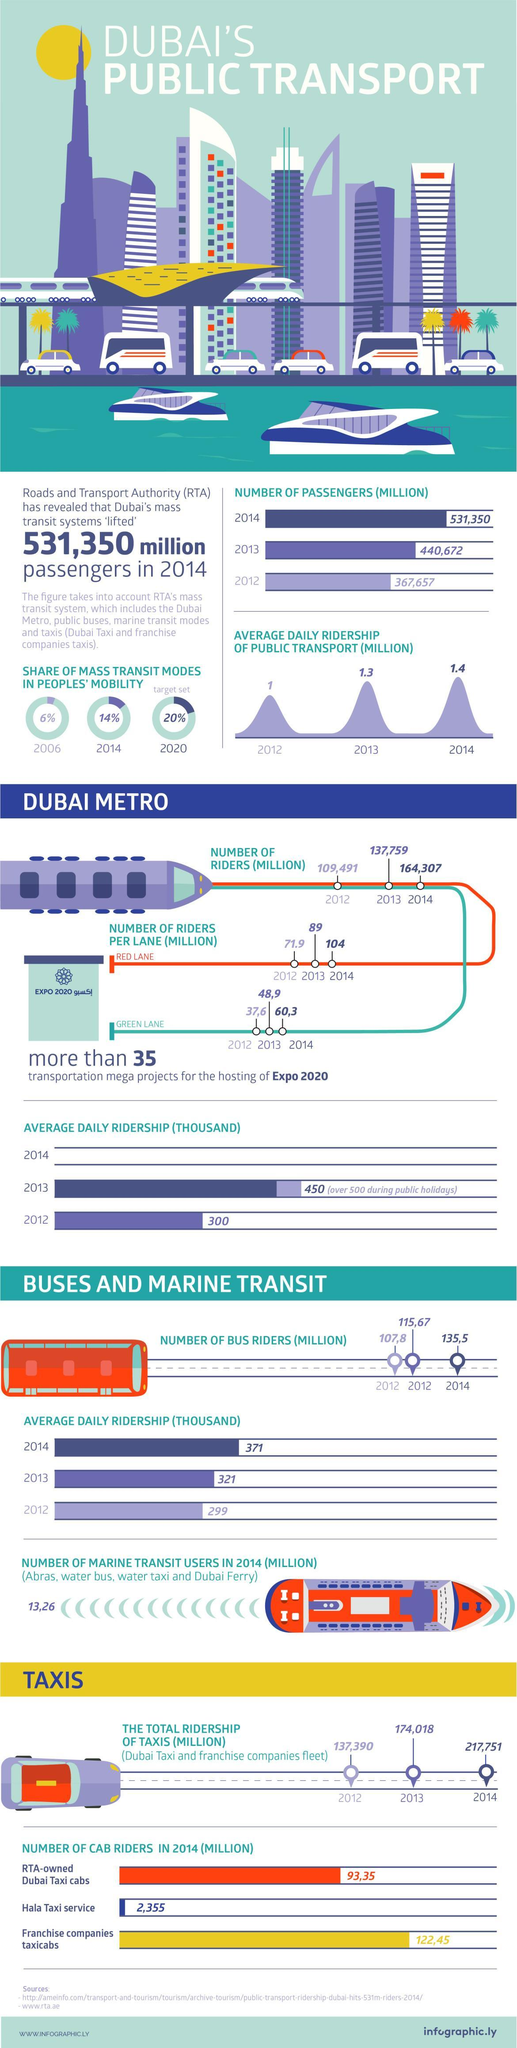What is the number of riders per green lane (in million) in Dubai metro in the year 2014?
Answer the question with a short phrase. 60,3 What is the percentage share of mass transit modes in people's mobility in Dubai in the year 2020? 20% What is the number of riders per red lane (in million) in Dubai metro in the year 2014? 104 What is the percentage share of mass transit modes in people's mobility in Dubai in the year 2014? 14% What is the number of riders per red lane (in million) in Dubai metro in the year 2013? 89 What is the average daily ridership of public transport (in million) in Dubai in the year 2014? 1.4 What is the number of bus riders (in million) in Dubai in the year 2014? 135,5 What is the total ridership of taxis (in million) in Dubai in the year 2013? 174,018 What is the average daily ridership of public transport (in million) in Dubai in the year 2012? 1 What are the two lanes available in Dubai metro? RED LANE, GREEN LANE 